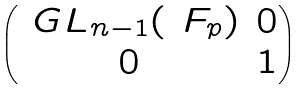Convert formula to latex. <formula><loc_0><loc_0><loc_500><loc_500>\begin{pmatrix} \ G L _ { n - 1 } ( \ F _ { p } ) & 0 \\ 0 & 1 \end{pmatrix}</formula> 